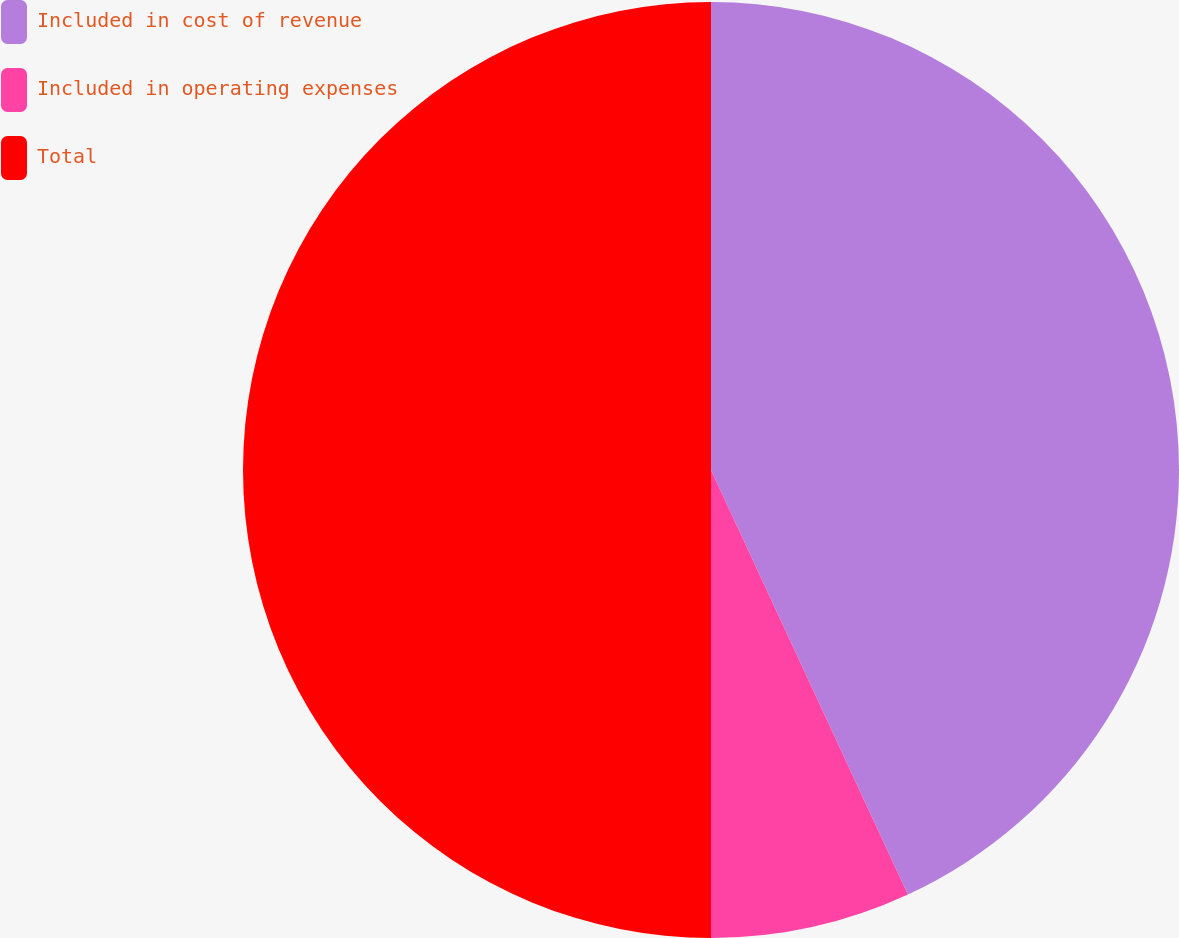Convert chart. <chart><loc_0><loc_0><loc_500><loc_500><pie_chart><fcel>Included in cost of revenue<fcel>Included in operating expenses<fcel>Total<nl><fcel>43.09%<fcel>6.91%<fcel>50.0%<nl></chart> 